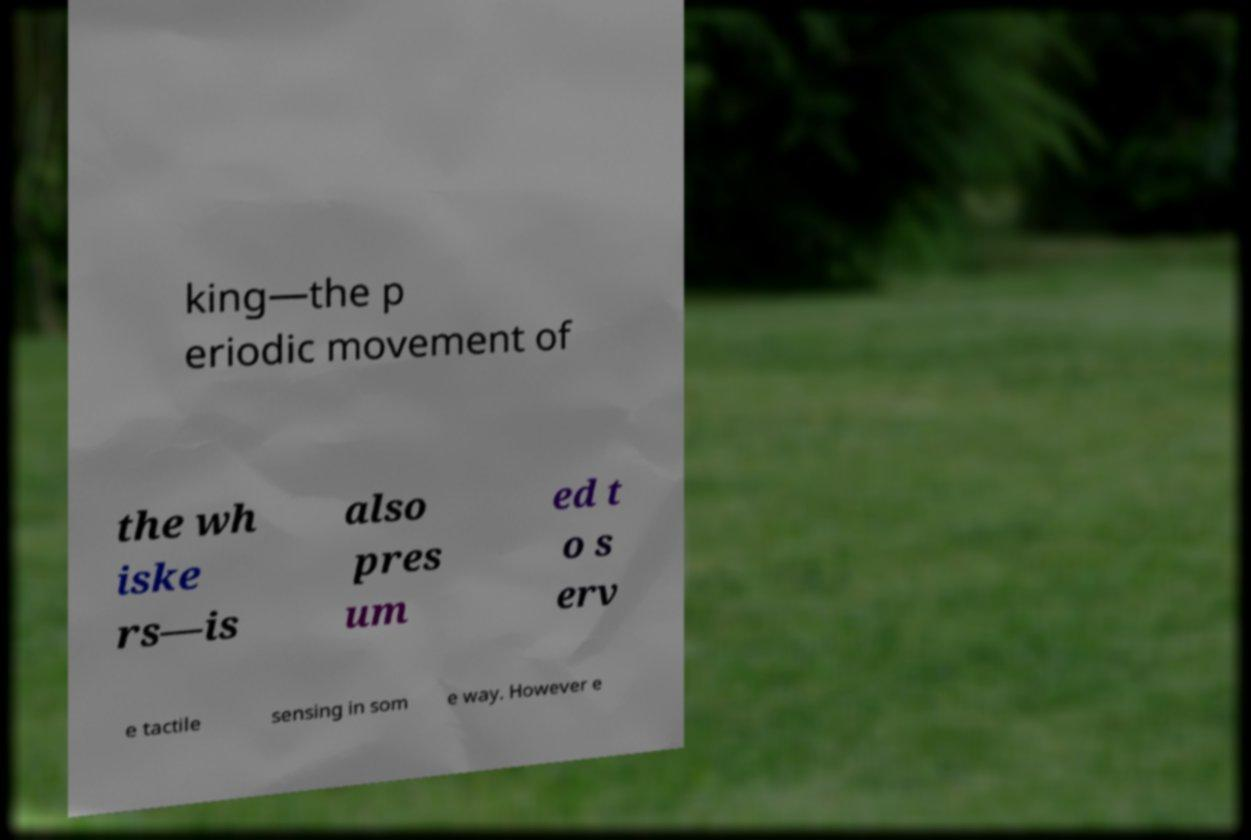Can you accurately transcribe the text from the provided image for me? king—the p eriodic movement of the wh iske rs—is also pres um ed t o s erv e tactile sensing in som e way. However e 